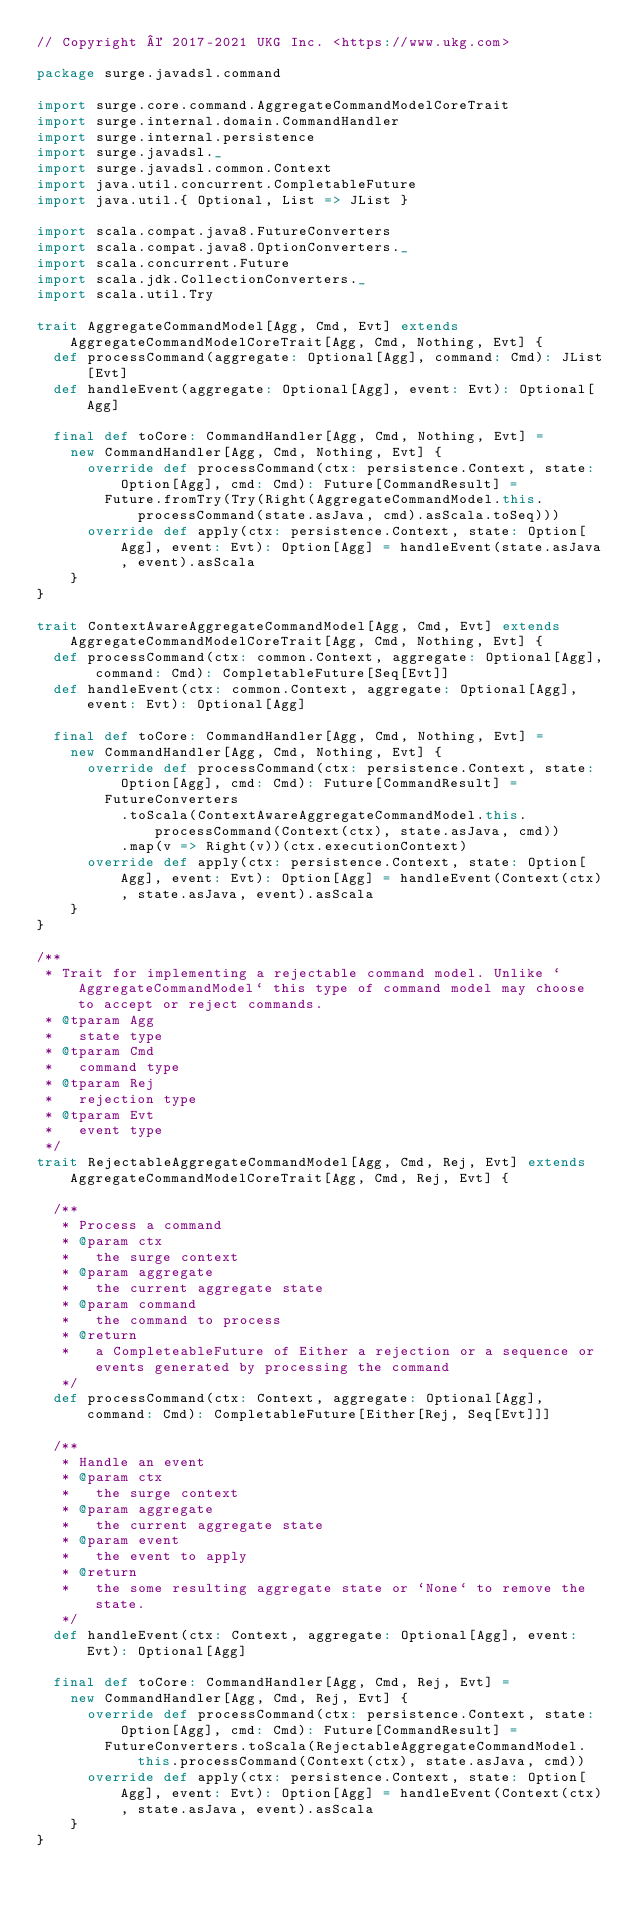<code> <loc_0><loc_0><loc_500><loc_500><_Scala_>// Copyright © 2017-2021 UKG Inc. <https://www.ukg.com>

package surge.javadsl.command

import surge.core.command.AggregateCommandModelCoreTrait
import surge.internal.domain.CommandHandler
import surge.internal.persistence
import surge.javadsl._
import surge.javadsl.common.Context
import java.util.concurrent.CompletableFuture
import java.util.{ Optional, List => JList }

import scala.compat.java8.FutureConverters
import scala.compat.java8.OptionConverters._
import scala.concurrent.Future
import scala.jdk.CollectionConverters._
import scala.util.Try

trait AggregateCommandModel[Agg, Cmd, Evt] extends AggregateCommandModelCoreTrait[Agg, Cmd, Nothing, Evt] {
  def processCommand(aggregate: Optional[Agg], command: Cmd): JList[Evt]
  def handleEvent(aggregate: Optional[Agg], event: Evt): Optional[Agg]

  final def toCore: CommandHandler[Agg, Cmd, Nothing, Evt] =
    new CommandHandler[Agg, Cmd, Nothing, Evt] {
      override def processCommand(ctx: persistence.Context, state: Option[Agg], cmd: Cmd): Future[CommandResult] =
        Future.fromTry(Try(Right(AggregateCommandModel.this.processCommand(state.asJava, cmd).asScala.toSeq)))
      override def apply(ctx: persistence.Context, state: Option[Agg], event: Evt): Option[Agg] = handleEvent(state.asJava, event).asScala
    }
}

trait ContextAwareAggregateCommandModel[Agg, Cmd, Evt] extends AggregateCommandModelCoreTrait[Agg, Cmd, Nothing, Evt] {
  def processCommand(ctx: common.Context, aggregate: Optional[Agg], command: Cmd): CompletableFuture[Seq[Evt]]
  def handleEvent(ctx: common.Context, aggregate: Optional[Agg], event: Evt): Optional[Agg]

  final def toCore: CommandHandler[Agg, Cmd, Nothing, Evt] =
    new CommandHandler[Agg, Cmd, Nothing, Evt] {
      override def processCommand(ctx: persistence.Context, state: Option[Agg], cmd: Cmd): Future[CommandResult] =
        FutureConverters
          .toScala(ContextAwareAggregateCommandModel.this.processCommand(Context(ctx), state.asJava, cmd))
          .map(v => Right(v))(ctx.executionContext)
      override def apply(ctx: persistence.Context, state: Option[Agg], event: Evt): Option[Agg] = handleEvent(Context(ctx), state.asJava, event).asScala
    }
}

/**
 * Trait for implementing a rejectable command model. Unlike `AggregateCommandModel` this type of command model may choose to accept or reject commands.
 * @tparam Agg
 *   state type
 * @tparam Cmd
 *   command type
 * @tparam Rej
 *   rejection type
 * @tparam Evt
 *   event type
 */
trait RejectableAggregateCommandModel[Agg, Cmd, Rej, Evt] extends AggregateCommandModelCoreTrait[Agg, Cmd, Rej, Evt] {

  /**
   * Process a command
   * @param ctx
   *   the surge context
   * @param aggregate
   *   the current aggregate state
   * @param command
   *   the command to process
   * @return
   *   a CompleteableFuture of Either a rejection or a sequence or events generated by processing the command
   */
  def processCommand(ctx: Context, aggregate: Optional[Agg], command: Cmd): CompletableFuture[Either[Rej, Seq[Evt]]]

  /**
   * Handle an event
   * @param ctx
   *   the surge context
   * @param aggregate
   *   the current aggregate state
   * @param event
   *   the event to apply
   * @return
   *   the some resulting aggregate state or `None` to remove the state.
   */
  def handleEvent(ctx: Context, aggregate: Optional[Agg], event: Evt): Optional[Agg]

  final def toCore: CommandHandler[Agg, Cmd, Rej, Evt] =
    new CommandHandler[Agg, Cmd, Rej, Evt] {
      override def processCommand(ctx: persistence.Context, state: Option[Agg], cmd: Cmd): Future[CommandResult] =
        FutureConverters.toScala(RejectableAggregateCommandModel.this.processCommand(Context(ctx), state.asJava, cmd))
      override def apply(ctx: persistence.Context, state: Option[Agg], event: Evt): Option[Agg] = handleEvent(Context(ctx), state.asJava, event).asScala
    }
}
</code> 